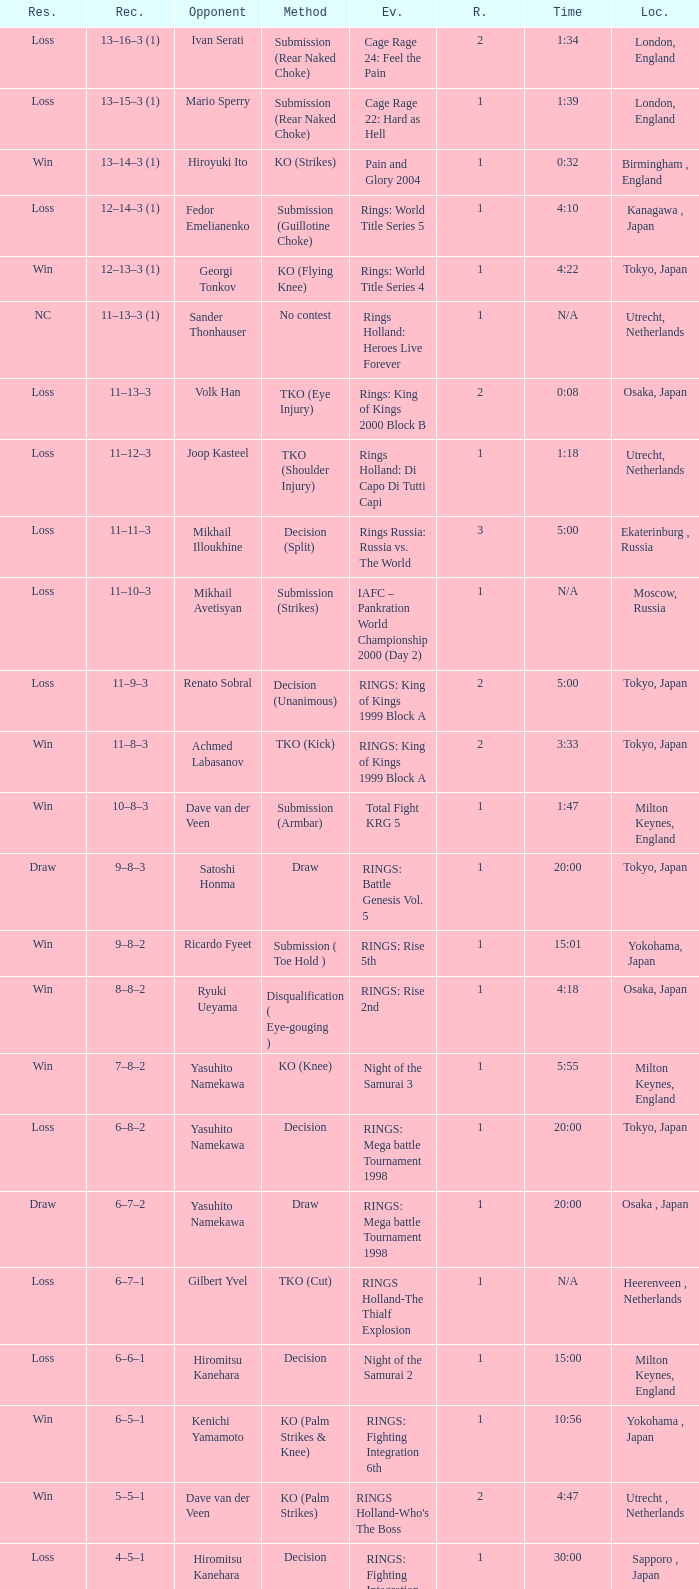What is the time for an opponent of Satoshi Honma? 20:00. 